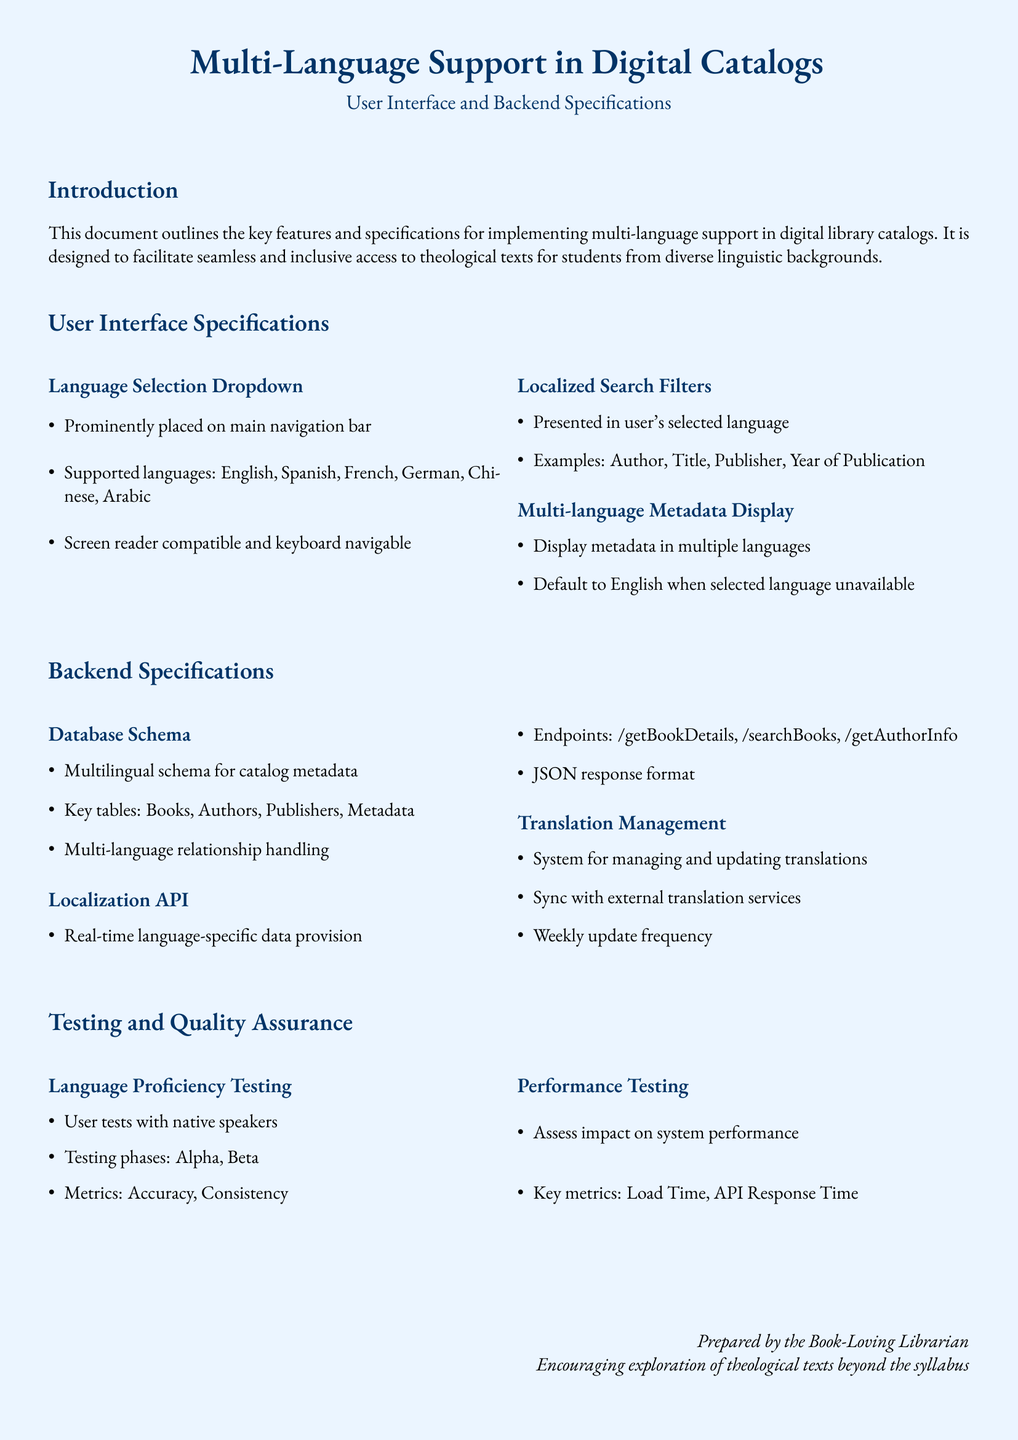What are the supported languages? The document lists the languages that are supported in the language selection dropdown, which are English, Spanish, French, German, Chinese, and Arabic.
Answer: English, Spanish, French, German, Chinese, Arabic What is the default language for metadata display? The document states that when the selected language is unavailable, the metadata will default to English.
Answer: English How frequently is the translation update scheduled? The document specifies that translation updates are scheduled to occur weekly.
Answer: Weekly What are the key phases of testing mentioned? The document outlines two testing phases, which are Alpha and Beta for user tests with native speakers.
Answer: Alpha, Beta What are the key tables in the database schema? The document lists the main tables included in the multilingual schema for catalog metadata, which are Books, Authors, Publishers, and Metadata.
Answer: Books, Authors, Publishers, Metadata What does the localization API provide? The document mentions that the Localization API is designed for real-time language-specific data provision.
Answer: Real-time language-specific data provision How is system performance assessed? The document describes key metrics used for testing system performance, which include Load Time and API Response Time.
Answer: Load Time, API Response Time Where is the language selection dropdown located? According to the document, the language selection dropdown is prominently placed on the main navigation bar.
Answer: Main navigation bar 